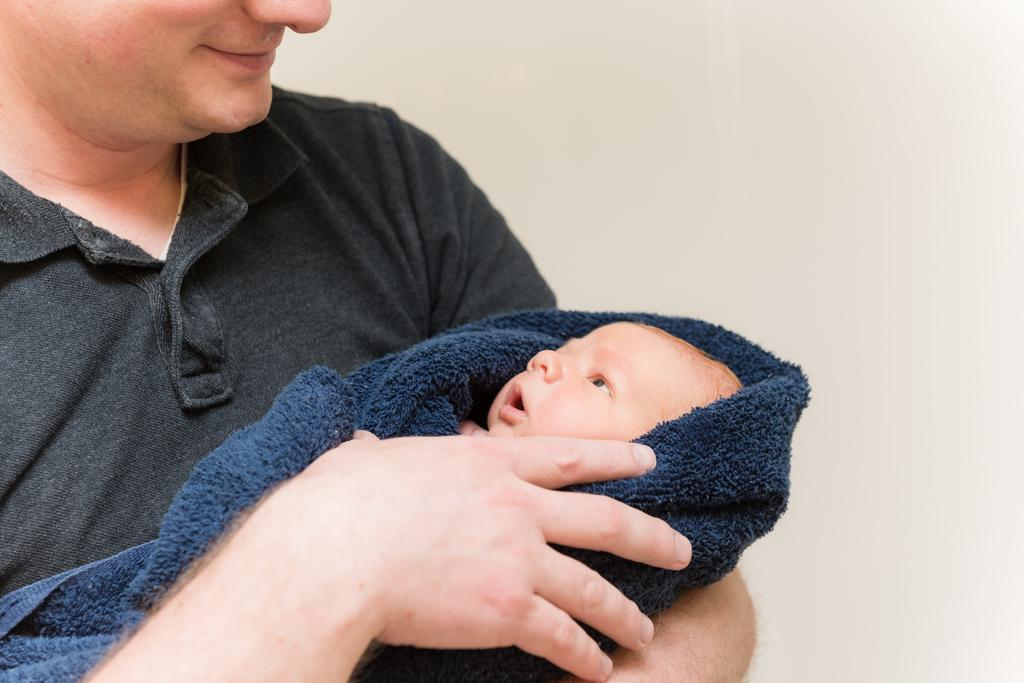What is the person in the image doing? The person is holding a baby in the image. How is the baby dressed or covered? The baby is wrapped in cloth. What can be seen in the background of the image? There is a wall in the background of the image. How does the person in the image compare to the baby in terms of smiling? The image does not show the person or the baby smiling, so it is not possible to make a comparison. 